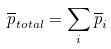<formula> <loc_0><loc_0><loc_500><loc_500>\overline { p } _ { t o t a l } = \sum _ { i } \overline { p } _ { i }</formula> 